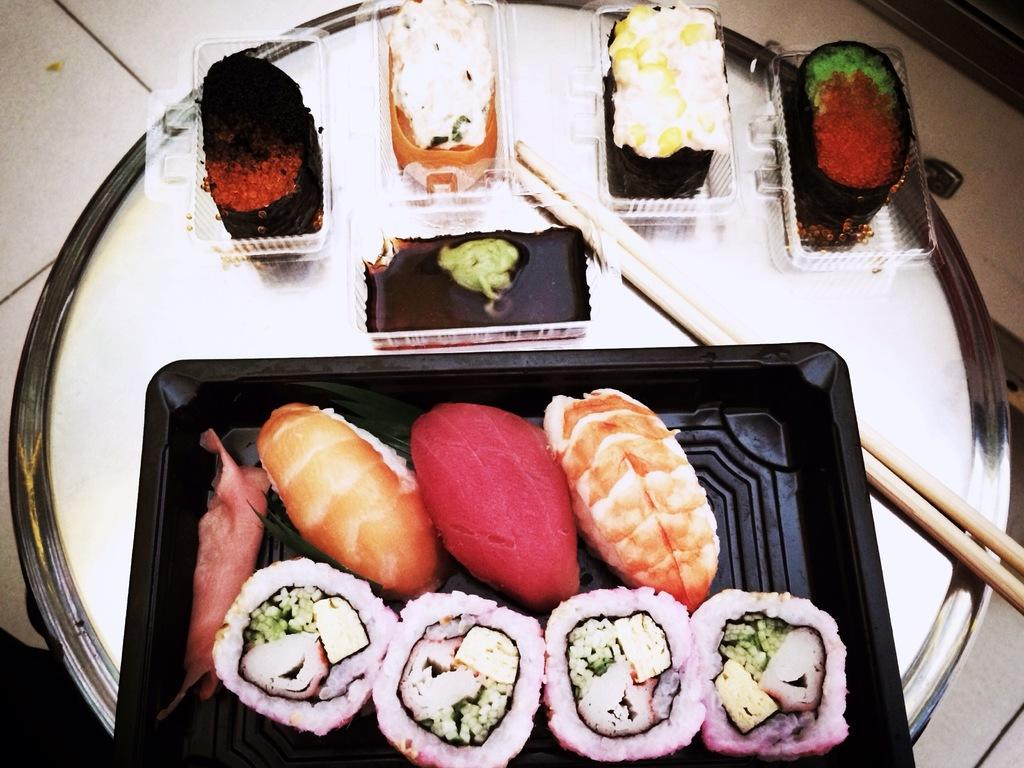What is present on the plate in the image? There are food items in a plastic container on the plate. What utensils are visible in the image? Chopsticks are visible in the image. Where is the cannon located in the image? There is no cannon present in the image. What color is the zebra in the image? There is no zebra present in the image. 